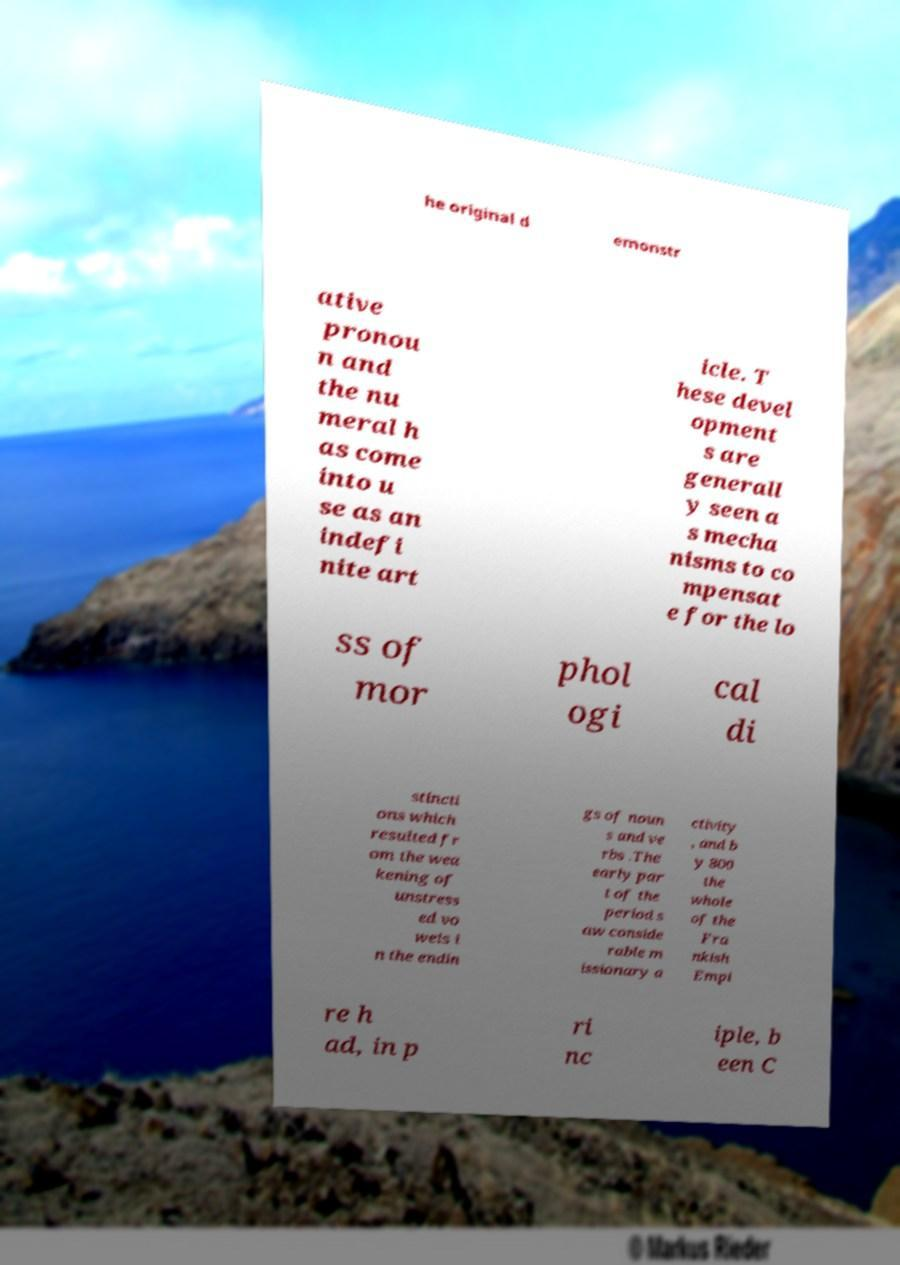Can you read and provide the text displayed in the image?This photo seems to have some interesting text. Can you extract and type it out for me? he original d emonstr ative pronou n and the nu meral h as come into u se as an indefi nite art icle. T hese devel opment s are generall y seen a s mecha nisms to co mpensat e for the lo ss of mor phol ogi cal di stincti ons which resulted fr om the wea kening of unstress ed vo wels i n the endin gs of noun s and ve rbs .The early par t of the period s aw conside rable m issionary a ctivity , and b y 800 the whole of the Fra nkish Empi re h ad, in p ri nc iple, b een C 